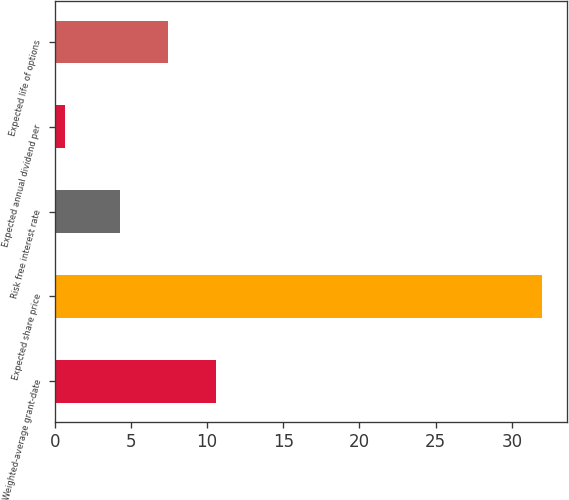Convert chart to OTSL. <chart><loc_0><loc_0><loc_500><loc_500><bar_chart><fcel>Weighted-average grant-date<fcel>Expected share price<fcel>Risk free interest rate<fcel>Expected annual dividend per<fcel>Expected life of options<nl><fcel>10.58<fcel>32<fcel>4.3<fcel>0.64<fcel>7.44<nl></chart> 